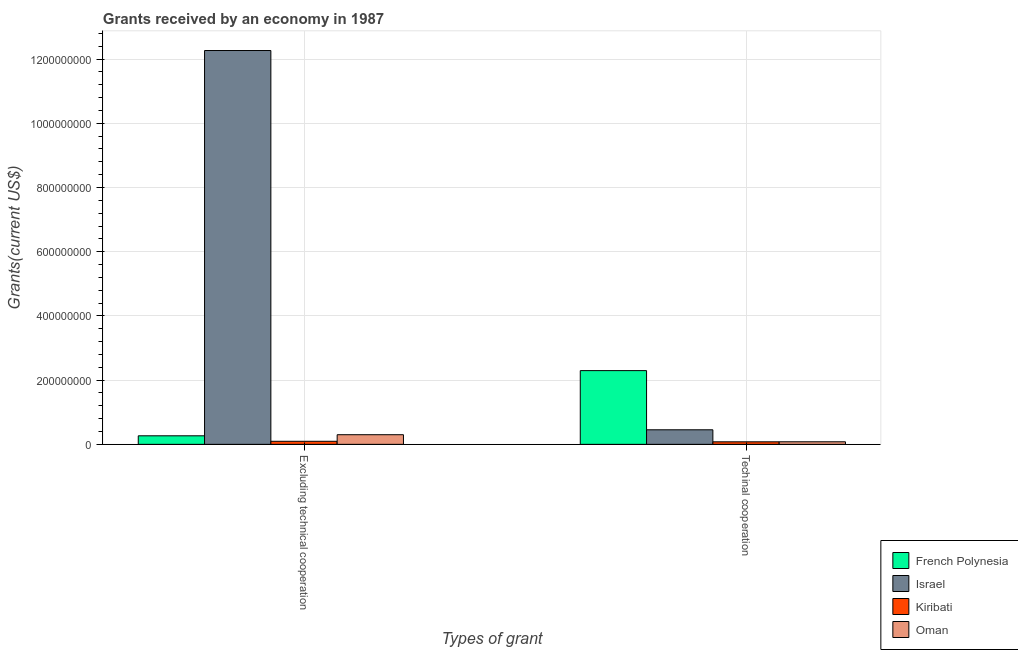How many different coloured bars are there?
Your response must be concise. 4. How many groups of bars are there?
Your response must be concise. 2. Are the number of bars on each tick of the X-axis equal?
Make the answer very short. Yes. How many bars are there on the 1st tick from the left?
Offer a very short reply. 4. What is the label of the 2nd group of bars from the left?
Make the answer very short. Techinal cooperation. What is the amount of grants received(including technical cooperation) in Oman?
Make the answer very short. 8.02e+06. Across all countries, what is the maximum amount of grants received(including technical cooperation)?
Offer a very short reply. 2.30e+08. Across all countries, what is the minimum amount of grants received(excluding technical cooperation)?
Your answer should be very brief. 9.58e+06. In which country was the amount of grants received(including technical cooperation) maximum?
Your answer should be very brief. French Polynesia. In which country was the amount of grants received(including technical cooperation) minimum?
Offer a very short reply. Kiribati. What is the total amount of grants received(excluding technical cooperation) in the graph?
Your answer should be very brief. 1.29e+09. What is the difference between the amount of grants received(excluding technical cooperation) in French Polynesia and that in Israel?
Keep it short and to the point. -1.20e+09. What is the difference between the amount of grants received(including technical cooperation) in Oman and the amount of grants received(excluding technical cooperation) in Kiribati?
Make the answer very short. -1.56e+06. What is the average amount of grants received(including technical cooperation) per country?
Your answer should be very brief. 7.27e+07. What is the difference between the amount of grants received(including technical cooperation) and amount of grants received(excluding technical cooperation) in Kiribati?
Keep it short and to the point. -1.68e+06. What is the ratio of the amount of grants received(including technical cooperation) in Israel to that in Oman?
Ensure brevity in your answer.  5.66. In how many countries, is the amount of grants received(excluding technical cooperation) greater than the average amount of grants received(excluding technical cooperation) taken over all countries?
Offer a very short reply. 1. What does the 3rd bar from the left in Techinal cooperation represents?
Provide a short and direct response. Kiribati. What does the 2nd bar from the right in Excluding technical cooperation represents?
Your answer should be very brief. Kiribati. How many bars are there?
Make the answer very short. 8. How many countries are there in the graph?
Offer a terse response. 4. How many legend labels are there?
Your response must be concise. 4. How are the legend labels stacked?
Give a very brief answer. Vertical. What is the title of the graph?
Give a very brief answer. Grants received by an economy in 1987. Does "Moldova" appear as one of the legend labels in the graph?
Your answer should be very brief. No. What is the label or title of the X-axis?
Your answer should be very brief. Types of grant. What is the label or title of the Y-axis?
Ensure brevity in your answer.  Grants(current US$). What is the Grants(current US$) in French Polynesia in Excluding technical cooperation?
Your answer should be very brief. 2.66e+07. What is the Grants(current US$) of Israel in Excluding technical cooperation?
Your answer should be compact. 1.23e+09. What is the Grants(current US$) in Kiribati in Excluding technical cooperation?
Offer a terse response. 9.58e+06. What is the Grants(current US$) in Oman in Excluding technical cooperation?
Provide a succinct answer. 3.00e+07. What is the Grants(current US$) in French Polynesia in Techinal cooperation?
Provide a short and direct response. 2.30e+08. What is the Grants(current US$) of Israel in Techinal cooperation?
Your response must be concise. 4.54e+07. What is the Grants(current US$) in Kiribati in Techinal cooperation?
Make the answer very short. 7.90e+06. What is the Grants(current US$) of Oman in Techinal cooperation?
Keep it short and to the point. 8.02e+06. Across all Types of grant, what is the maximum Grants(current US$) of French Polynesia?
Give a very brief answer. 2.30e+08. Across all Types of grant, what is the maximum Grants(current US$) in Israel?
Ensure brevity in your answer.  1.23e+09. Across all Types of grant, what is the maximum Grants(current US$) of Kiribati?
Offer a terse response. 9.58e+06. Across all Types of grant, what is the maximum Grants(current US$) in Oman?
Give a very brief answer. 3.00e+07. Across all Types of grant, what is the minimum Grants(current US$) in French Polynesia?
Keep it short and to the point. 2.66e+07. Across all Types of grant, what is the minimum Grants(current US$) in Israel?
Keep it short and to the point. 4.54e+07. Across all Types of grant, what is the minimum Grants(current US$) in Kiribati?
Provide a succinct answer. 7.90e+06. Across all Types of grant, what is the minimum Grants(current US$) of Oman?
Offer a very short reply. 8.02e+06. What is the total Grants(current US$) of French Polynesia in the graph?
Ensure brevity in your answer.  2.56e+08. What is the total Grants(current US$) in Israel in the graph?
Offer a terse response. 1.27e+09. What is the total Grants(current US$) in Kiribati in the graph?
Your response must be concise. 1.75e+07. What is the total Grants(current US$) in Oman in the graph?
Make the answer very short. 3.80e+07. What is the difference between the Grants(current US$) of French Polynesia in Excluding technical cooperation and that in Techinal cooperation?
Provide a short and direct response. -2.03e+08. What is the difference between the Grants(current US$) of Israel in Excluding technical cooperation and that in Techinal cooperation?
Offer a very short reply. 1.18e+09. What is the difference between the Grants(current US$) of Kiribati in Excluding technical cooperation and that in Techinal cooperation?
Provide a succinct answer. 1.68e+06. What is the difference between the Grants(current US$) of Oman in Excluding technical cooperation and that in Techinal cooperation?
Keep it short and to the point. 2.20e+07. What is the difference between the Grants(current US$) of French Polynesia in Excluding technical cooperation and the Grants(current US$) of Israel in Techinal cooperation?
Offer a terse response. -1.87e+07. What is the difference between the Grants(current US$) in French Polynesia in Excluding technical cooperation and the Grants(current US$) in Kiribati in Techinal cooperation?
Provide a succinct answer. 1.87e+07. What is the difference between the Grants(current US$) of French Polynesia in Excluding technical cooperation and the Grants(current US$) of Oman in Techinal cooperation?
Your answer should be very brief. 1.86e+07. What is the difference between the Grants(current US$) in Israel in Excluding technical cooperation and the Grants(current US$) in Kiribati in Techinal cooperation?
Keep it short and to the point. 1.22e+09. What is the difference between the Grants(current US$) of Israel in Excluding technical cooperation and the Grants(current US$) of Oman in Techinal cooperation?
Make the answer very short. 1.22e+09. What is the difference between the Grants(current US$) in Kiribati in Excluding technical cooperation and the Grants(current US$) in Oman in Techinal cooperation?
Offer a terse response. 1.56e+06. What is the average Grants(current US$) of French Polynesia per Types of grant?
Give a very brief answer. 1.28e+08. What is the average Grants(current US$) in Israel per Types of grant?
Provide a succinct answer. 6.36e+08. What is the average Grants(current US$) of Kiribati per Types of grant?
Keep it short and to the point. 8.74e+06. What is the average Grants(current US$) of Oman per Types of grant?
Give a very brief answer. 1.90e+07. What is the difference between the Grants(current US$) of French Polynesia and Grants(current US$) of Israel in Excluding technical cooperation?
Ensure brevity in your answer.  -1.20e+09. What is the difference between the Grants(current US$) in French Polynesia and Grants(current US$) in Kiribati in Excluding technical cooperation?
Offer a terse response. 1.71e+07. What is the difference between the Grants(current US$) of French Polynesia and Grants(current US$) of Oman in Excluding technical cooperation?
Offer a very short reply. -3.39e+06. What is the difference between the Grants(current US$) in Israel and Grants(current US$) in Kiribati in Excluding technical cooperation?
Make the answer very short. 1.22e+09. What is the difference between the Grants(current US$) in Israel and Grants(current US$) in Oman in Excluding technical cooperation?
Your response must be concise. 1.20e+09. What is the difference between the Grants(current US$) of Kiribati and Grants(current US$) of Oman in Excluding technical cooperation?
Give a very brief answer. -2.04e+07. What is the difference between the Grants(current US$) of French Polynesia and Grants(current US$) of Israel in Techinal cooperation?
Your response must be concise. 1.84e+08. What is the difference between the Grants(current US$) of French Polynesia and Grants(current US$) of Kiribati in Techinal cooperation?
Offer a very short reply. 2.22e+08. What is the difference between the Grants(current US$) in French Polynesia and Grants(current US$) in Oman in Techinal cooperation?
Your answer should be compact. 2.22e+08. What is the difference between the Grants(current US$) in Israel and Grants(current US$) in Kiribati in Techinal cooperation?
Make the answer very short. 3.75e+07. What is the difference between the Grants(current US$) of Israel and Grants(current US$) of Oman in Techinal cooperation?
Provide a succinct answer. 3.74e+07. What is the difference between the Grants(current US$) of Kiribati and Grants(current US$) of Oman in Techinal cooperation?
Offer a very short reply. -1.20e+05. What is the ratio of the Grants(current US$) in French Polynesia in Excluding technical cooperation to that in Techinal cooperation?
Your answer should be compact. 0.12. What is the ratio of the Grants(current US$) of Israel in Excluding technical cooperation to that in Techinal cooperation?
Offer a terse response. 27.04. What is the ratio of the Grants(current US$) in Kiribati in Excluding technical cooperation to that in Techinal cooperation?
Give a very brief answer. 1.21. What is the ratio of the Grants(current US$) in Oman in Excluding technical cooperation to that in Techinal cooperation?
Your answer should be compact. 3.74. What is the difference between the highest and the second highest Grants(current US$) in French Polynesia?
Your answer should be compact. 2.03e+08. What is the difference between the highest and the second highest Grants(current US$) in Israel?
Provide a succinct answer. 1.18e+09. What is the difference between the highest and the second highest Grants(current US$) of Kiribati?
Offer a very short reply. 1.68e+06. What is the difference between the highest and the second highest Grants(current US$) in Oman?
Keep it short and to the point. 2.20e+07. What is the difference between the highest and the lowest Grants(current US$) in French Polynesia?
Ensure brevity in your answer.  2.03e+08. What is the difference between the highest and the lowest Grants(current US$) of Israel?
Provide a succinct answer. 1.18e+09. What is the difference between the highest and the lowest Grants(current US$) in Kiribati?
Your answer should be compact. 1.68e+06. What is the difference between the highest and the lowest Grants(current US$) in Oman?
Keep it short and to the point. 2.20e+07. 